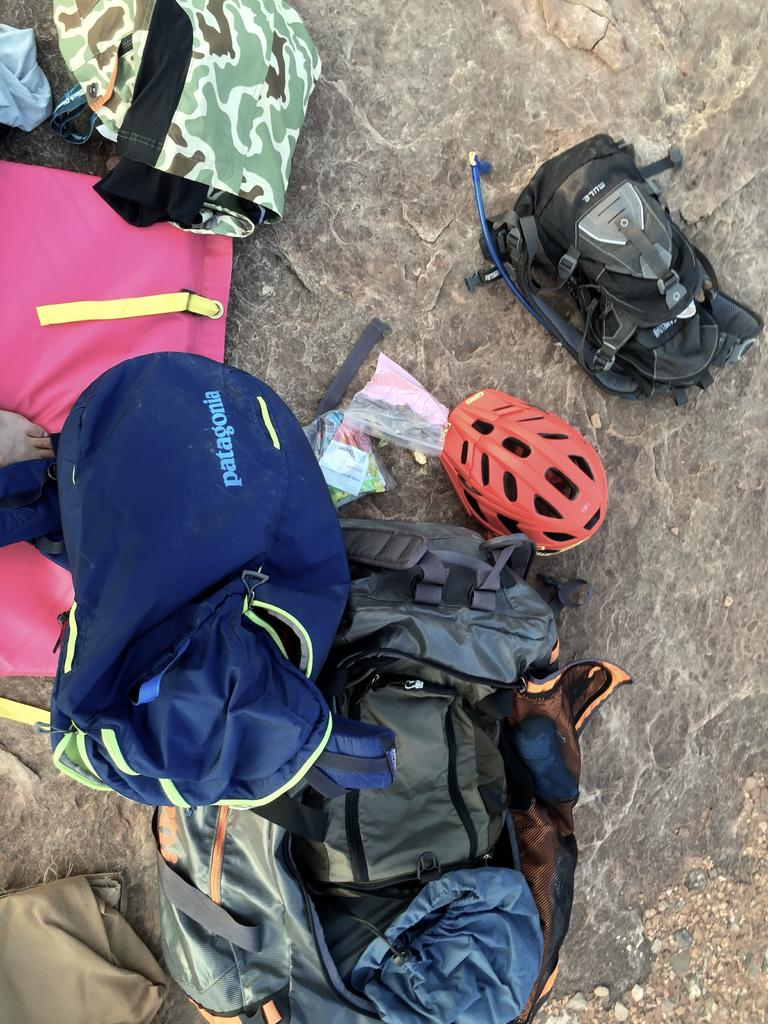What objects are on the ground in the image? There are bags and a helmet on the ground. What type of effect does the flame have on the bags in the image? There is no flame present in the image, so it is not possible to determine the effect it might have on the bags. 